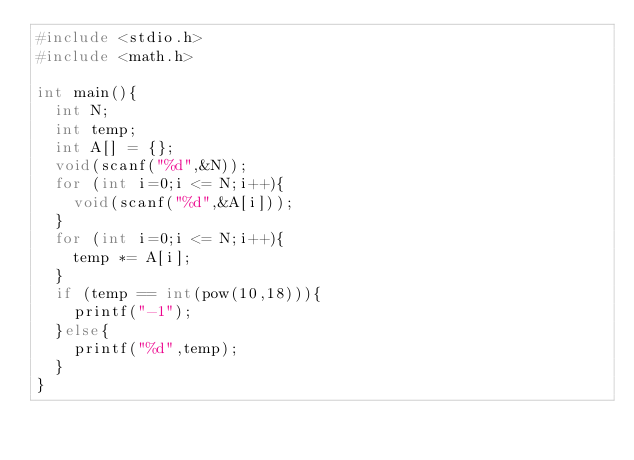Convert code to text. <code><loc_0><loc_0><loc_500><loc_500><_C_>#include <stdio.h>
#include <math.h>
 
int main(){
  int N;
  int temp;
  int A[] = {};
  void(scanf("%d",&N));
  for (int i=0;i <= N;i++){
    void(scanf("%d",&A[i]));
  }
  for (int i=0;i <= N;i++){
    temp *= A[i];
  }
  if (temp == int(pow(10,18))){
    printf("-1");
  }else{
    printf("%d",temp);
  }
}</code> 